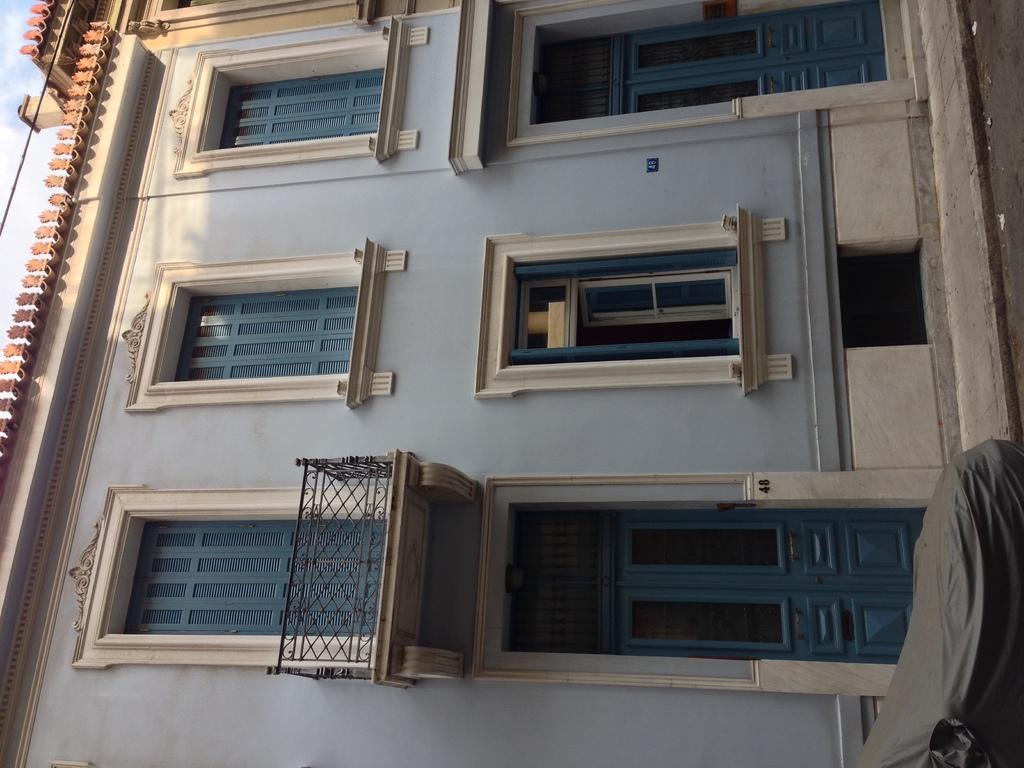Can you describe this image briefly? In this image I can see a building, in the top left I can see the sky, in the bottom right I can see a cloth and a road on the right side. 